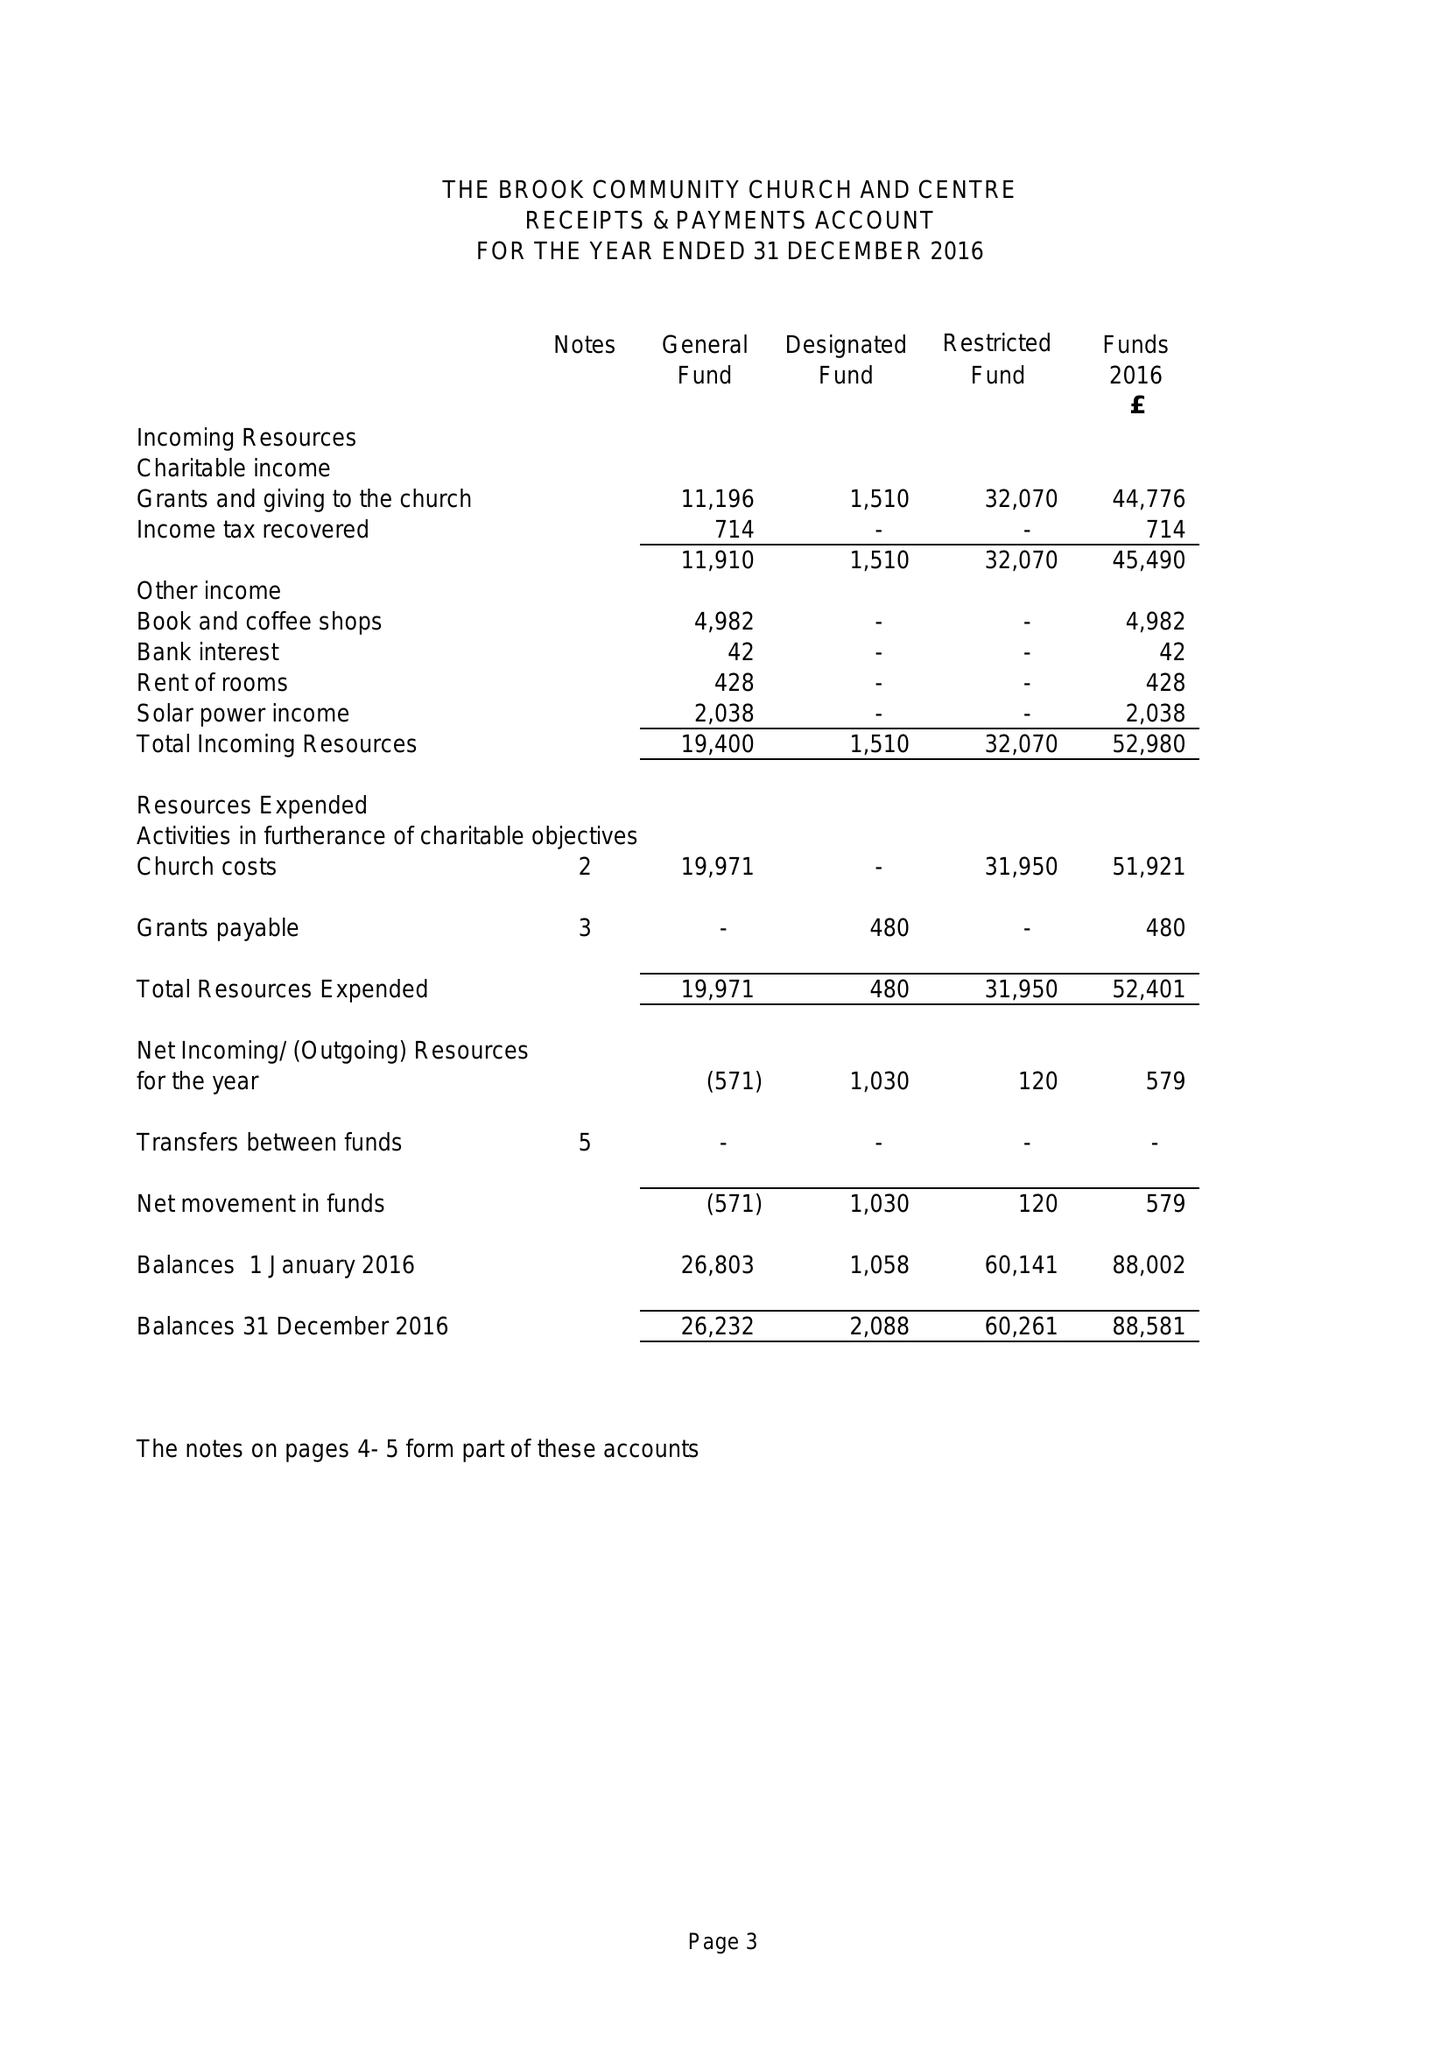What is the value for the address__street_line?
Answer the question using a single word or phrase. None 